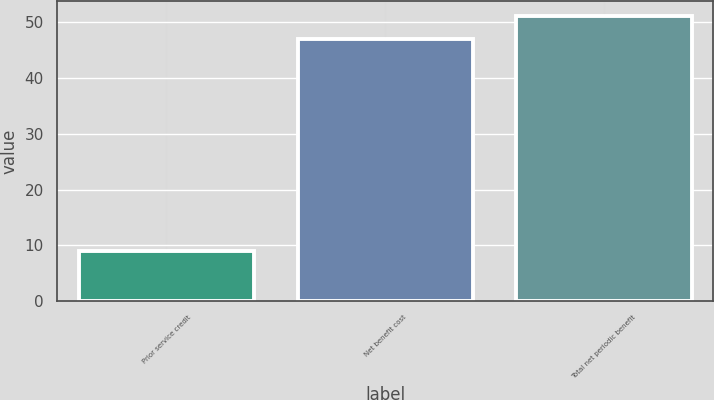Convert chart. <chart><loc_0><loc_0><loc_500><loc_500><bar_chart><fcel>Prior service credit<fcel>Net benefit cost<fcel>Total net periodic benefit<nl><fcel>9<fcel>47<fcel>51.1<nl></chart> 